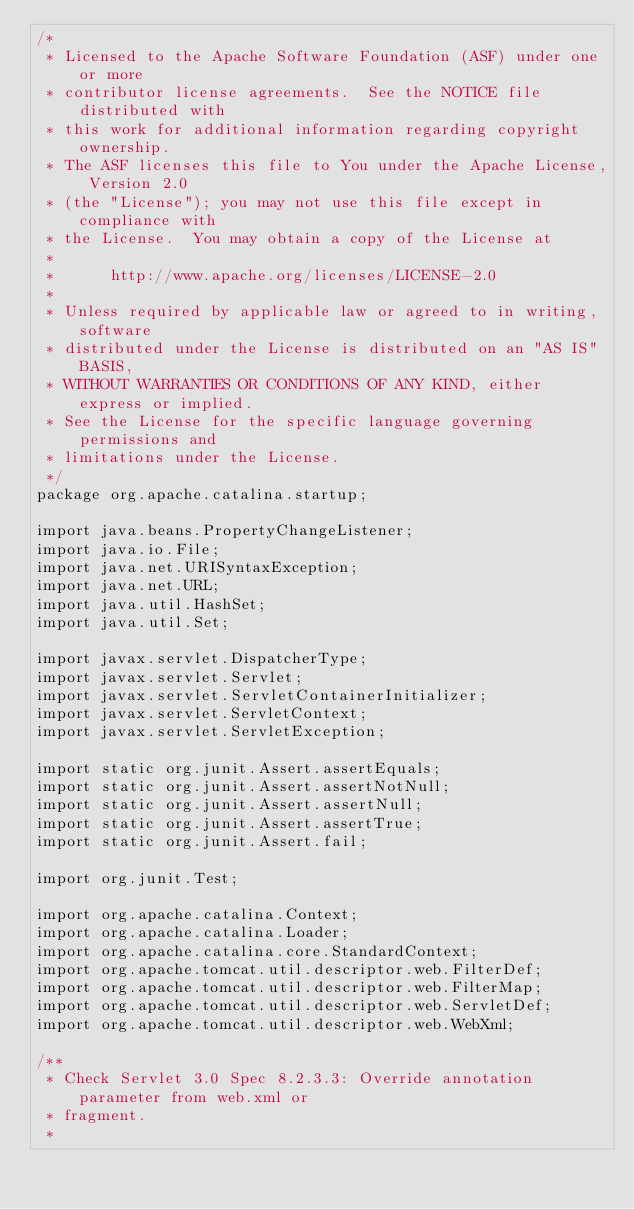Convert code to text. <code><loc_0><loc_0><loc_500><loc_500><_Java_>/*
 * Licensed to the Apache Software Foundation (ASF) under one or more
 * contributor license agreements.  See the NOTICE file distributed with
 * this work for additional information regarding copyright ownership.
 * The ASF licenses this file to You under the Apache License, Version 2.0
 * (the "License"); you may not use this file except in compliance with
 * the License.  You may obtain a copy of the License at
 *
 *      http://www.apache.org/licenses/LICENSE-2.0
 *
 * Unless required by applicable law or agreed to in writing, software
 * distributed under the License is distributed on an "AS IS" BASIS,
 * WITHOUT WARRANTIES OR CONDITIONS OF ANY KIND, either express or implied.
 * See the License for the specific language governing permissions and
 * limitations under the License.
 */
package org.apache.catalina.startup;

import java.beans.PropertyChangeListener;
import java.io.File;
import java.net.URISyntaxException;
import java.net.URL;
import java.util.HashSet;
import java.util.Set;

import javax.servlet.DispatcherType;
import javax.servlet.Servlet;
import javax.servlet.ServletContainerInitializer;
import javax.servlet.ServletContext;
import javax.servlet.ServletException;

import static org.junit.Assert.assertEquals;
import static org.junit.Assert.assertNotNull;
import static org.junit.Assert.assertNull;
import static org.junit.Assert.assertTrue;
import static org.junit.Assert.fail;

import org.junit.Test;

import org.apache.catalina.Context;
import org.apache.catalina.Loader;
import org.apache.catalina.core.StandardContext;
import org.apache.tomcat.util.descriptor.web.FilterDef;
import org.apache.tomcat.util.descriptor.web.FilterMap;
import org.apache.tomcat.util.descriptor.web.ServletDef;
import org.apache.tomcat.util.descriptor.web.WebXml;

/**
 * Check Servlet 3.0 Spec 8.2.3.3: Override annotation parameter from web.xml or
 * fragment.
 *</code> 